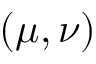Convert formula to latex. <formula><loc_0><loc_0><loc_500><loc_500>( \mu , \nu )</formula> 